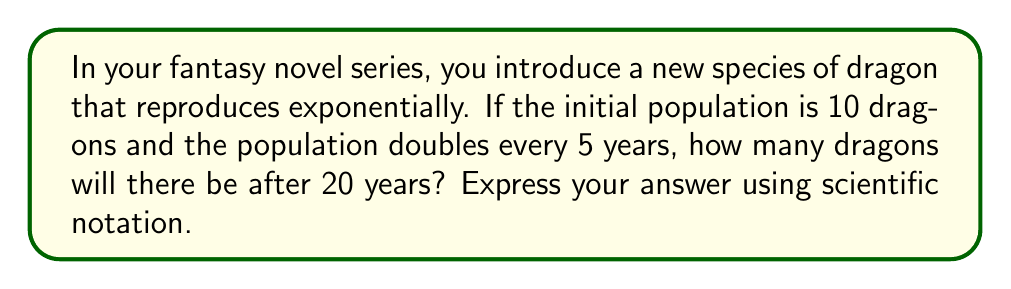Can you solve this math problem? Let's approach this step-by-step:

1) We're dealing with exponential growth, which can be modeled by the function:

   $P(t) = P_0 \cdot a^t$

   Where:
   $P(t)$ is the population at time $t$
   $P_0$ is the initial population
   $a$ is the growth factor
   $t$ is the time

2) We're given:
   $P_0 = 10$ (initial population)
   The population doubles every 5 years, so $a = 2^{\frac{1}{5}}$
   $t = 20$ years

3) Let's calculate $a^t$:

   $a^t = (2^{\frac{1}{5}})^{20} = 2^4 = 16$

4) Now we can plug everything into our equation:

   $P(20) = 10 \cdot 16 = 160$

5) To express this in scientific notation:

   $160 = 1.6 \times 10^2$

Therefore, after 20 years, there will be $1.6 \times 10^2$ dragons.
Answer: $1.6 \times 10^2$ dragons 